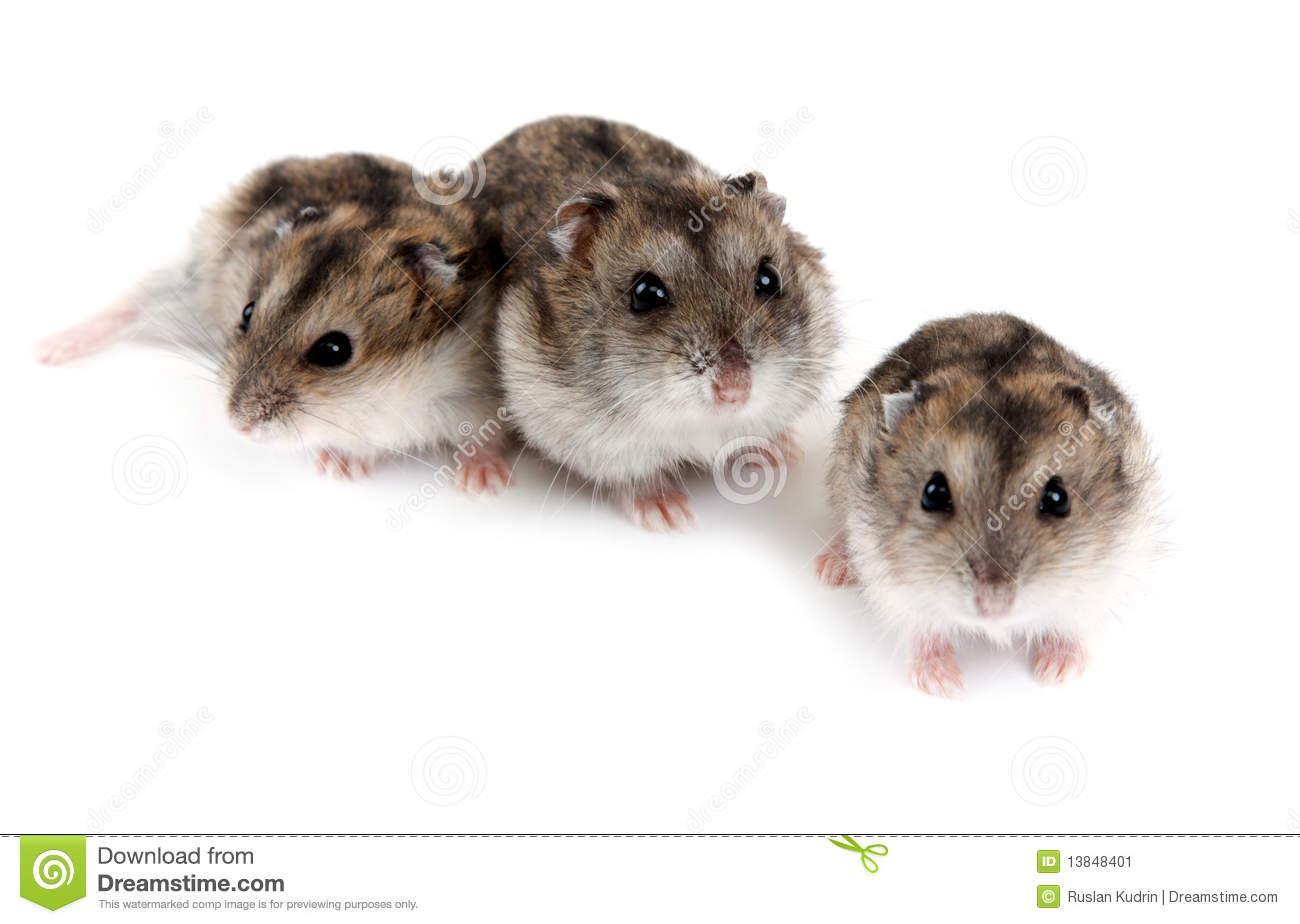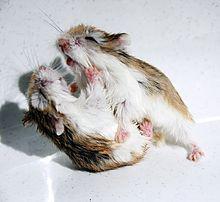The first image is the image on the left, the second image is the image on the right. Analyze the images presented: Is the assertion "The animal in the image on the right is in an upright vertical position on its hind legs." valid? Answer yes or no. No. The first image is the image on the left, the second image is the image on the right. Considering the images on both sides, is "The left photo contains multiple animals." valid? Answer yes or no. Yes. 